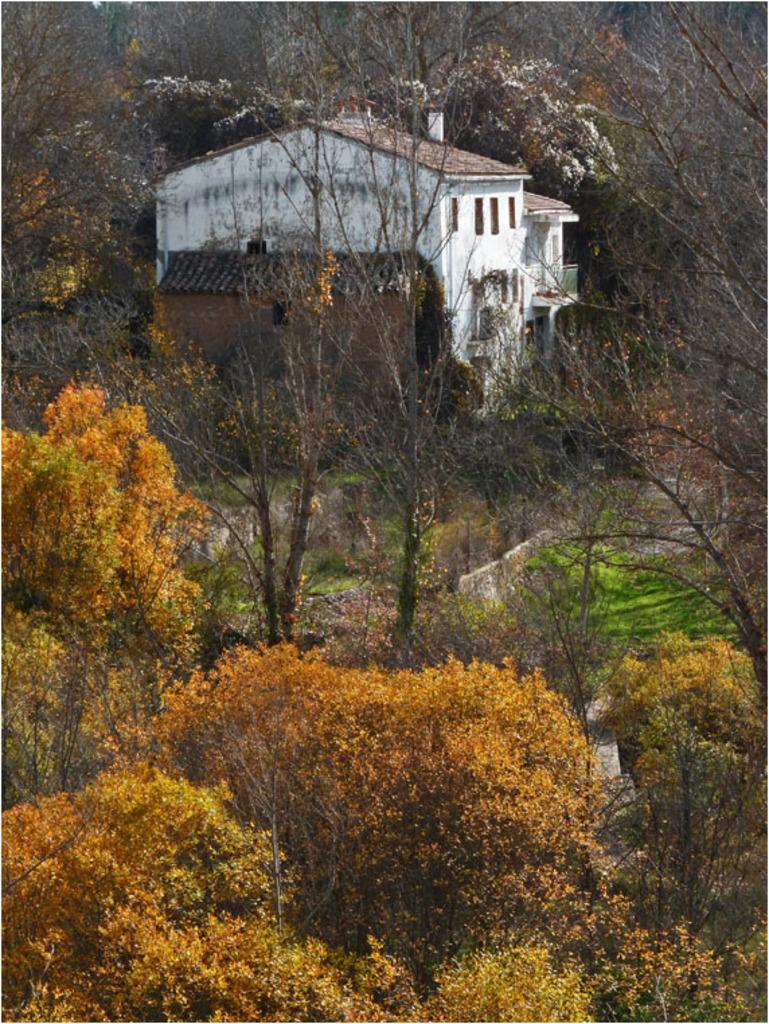What type of structure is visible in the image? There is a house in the image. What can be seen beneath the house? The ground is visible in the image. What type of vegetation is present in the image? There is grass, plants, and trees in the image. What is the manager's role in relation to the brick in the image? There is no manager or brick present in the image. 